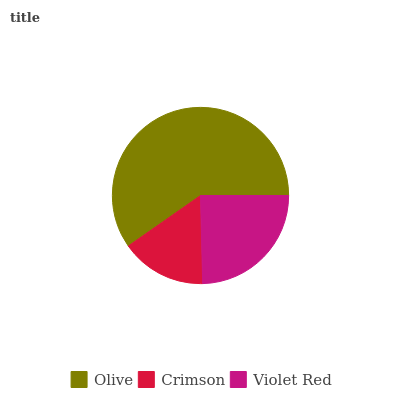Is Crimson the minimum?
Answer yes or no. Yes. Is Olive the maximum?
Answer yes or no. Yes. Is Violet Red the minimum?
Answer yes or no. No. Is Violet Red the maximum?
Answer yes or no. No. Is Violet Red greater than Crimson?
Answer yes or no. Yes. Is Crimson less than Violet Red?
Answer yes or no. Yes. Is Crimson greater than Violet Red?
Answer yes or no. No. Is Violet Red less than Crimson?
Answer yes or no. No. Is Violet Red the high median?
Answer yes or no. Yes. Is Violet Red the low median?
Answer yes or no. Yes. Is Olive the high median?
Answer yes or no. No. Is Crimson the low median?
Answer yes or no. No. 